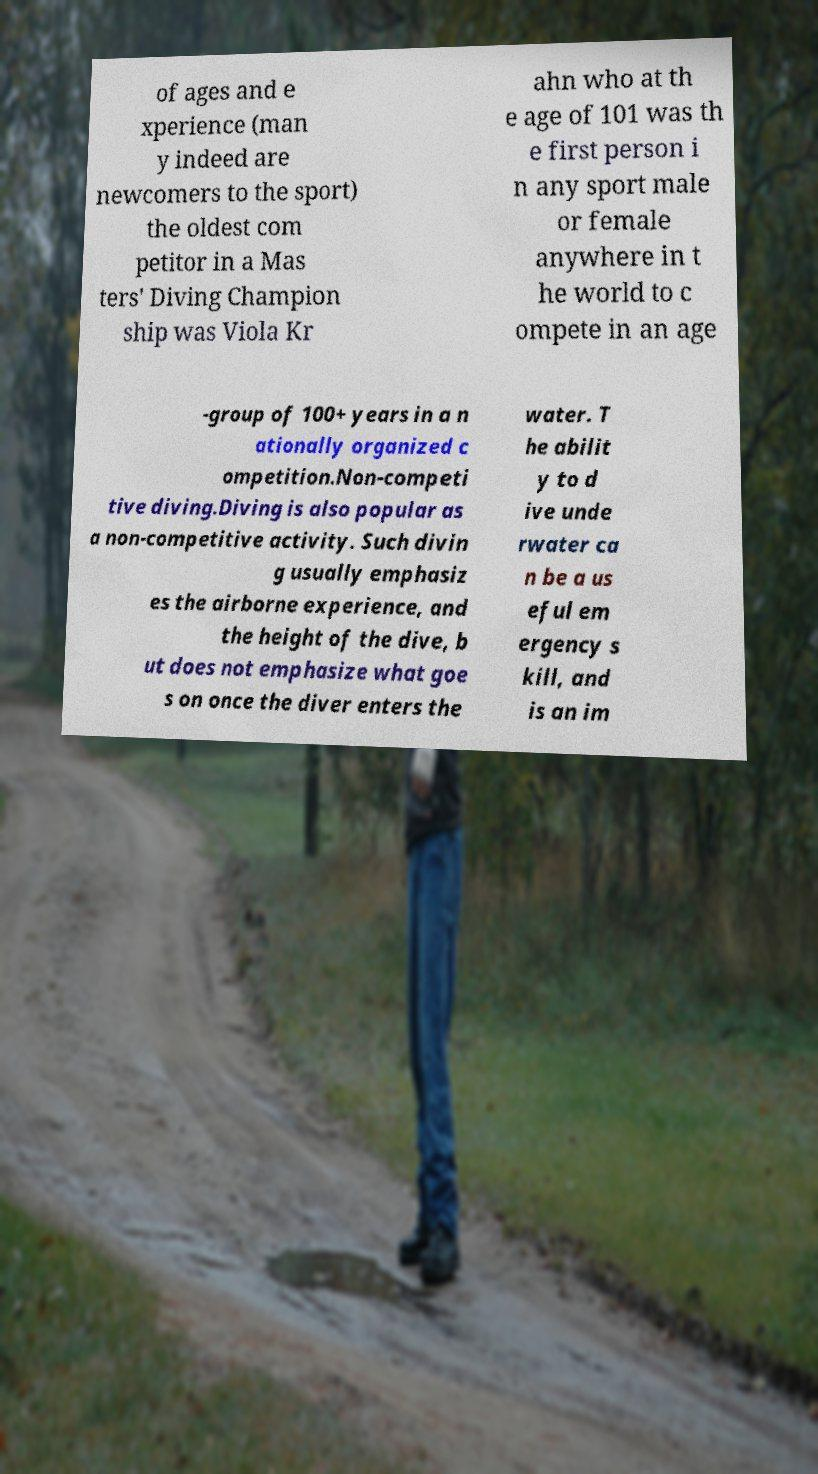What messages or text are displayed in this image? I need them in a readable, typed format. of ages and e xperience (man y indeed are newcomers to the sport) the oldest com petitor in a Mas ters' Diving Champion ship was Viola Kr ahn who at th e age of 101 was th e first person i n any sport male or female anywhere in t he world to c ompete in an age -group of 100+ years in a n ationally organized c ompetition.Non-competi tive diving.Diving is also popular as a non-competitive activity. Such divin g usually emphasiz es the airborne experience, and the height of the dive, b ut does not emphasize what goe s on once the diver enters the water. T he abilit y to d ive unde rwater ca n be a us eful em ergency s kill, and is an im 